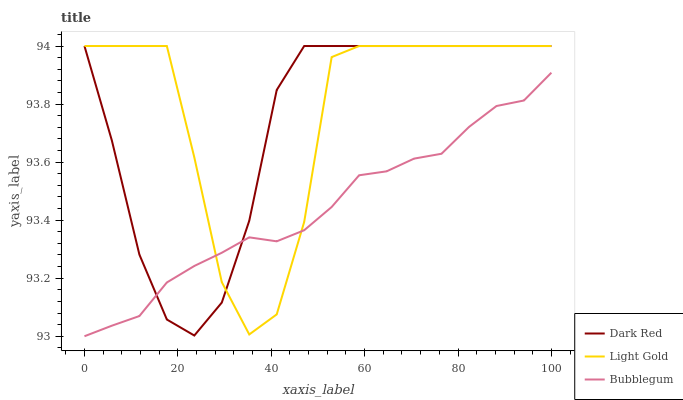Does Bubblegum have the minimum area under the curve?
Answer yes or no. Yes. Does Light Gold have the maximum area under the curve?
Answer yes or no. Yes. Does Light Gold have the minimum area under the curve?
Answer yes or no. No. Does Bubblegum have the maximum area under the curve?
Answer yes or no. No. Is Bubblegum the smoothest?
Answer yes or no. Yes. Is Light Gold the roughest?
Answer yes or no. Yes. Is Light Gold the smoothest?
Answer yes or no. No. Is Bubblegum the roughest?
Answer yes or no. No. Does Light Gold have the lowest value?
Answer yes or no. No. Does Light Gold have the highest value?
Answer yes or no. Yes. Does Bubblegum have the highest value?
Answer yes or no. No. Does Bubblegum intersect Light Gold?
Answer yes or no. Yes. Is Bubblegum less than Light Gold?
Answer yes or no. No. Is Bubblegum greater than Light Gold?
Answer yes or no. No. 